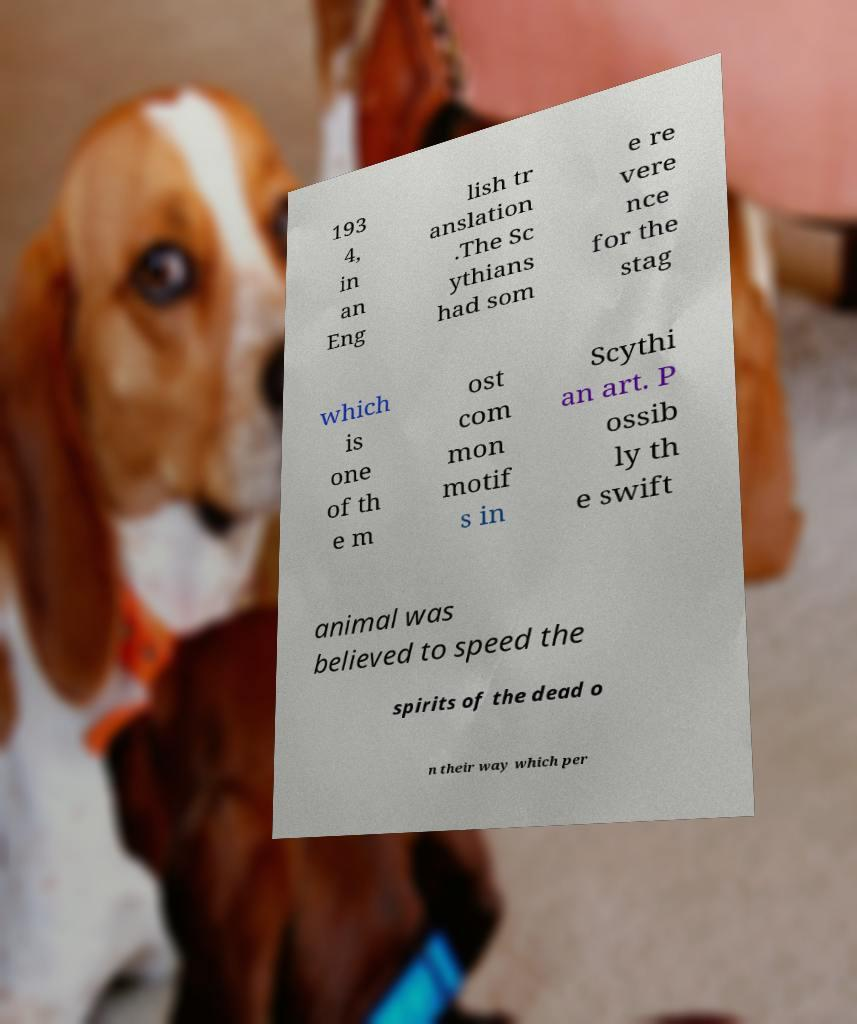For documentation purposes, I need the text within this image transcribed. Could you provide that? 193 4, in an Eng lish tr anslation .The Sc ythians had som e re vere nce for the stag which is one of th e m ost com mon motif s in Scythi an art. P ossib ly th e swift animal was believed to speed the spirits of the dead o n their way which per 